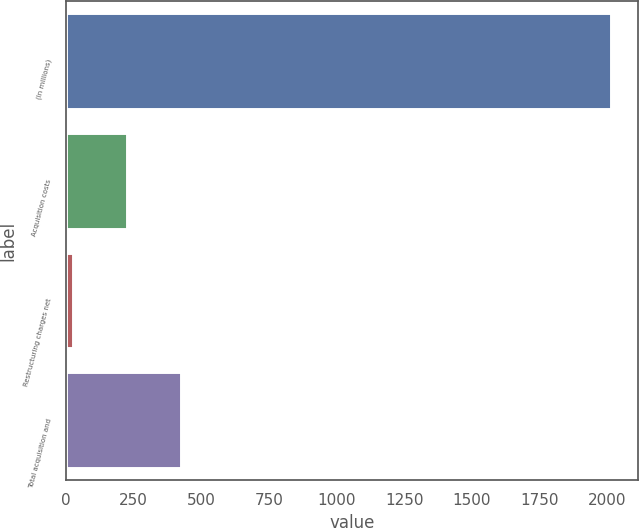Convert chart. <chart><loc_0><loc_0><loc_500><loc_500><bar_chart><fcel>(In millions)<fcel>Acquisition costs<fcel>Restructuring charges net<fcel>Total acquisition and<nl><fcel>2013<fcel>226.5<fcel>28<fcel>425<nl></chart> 